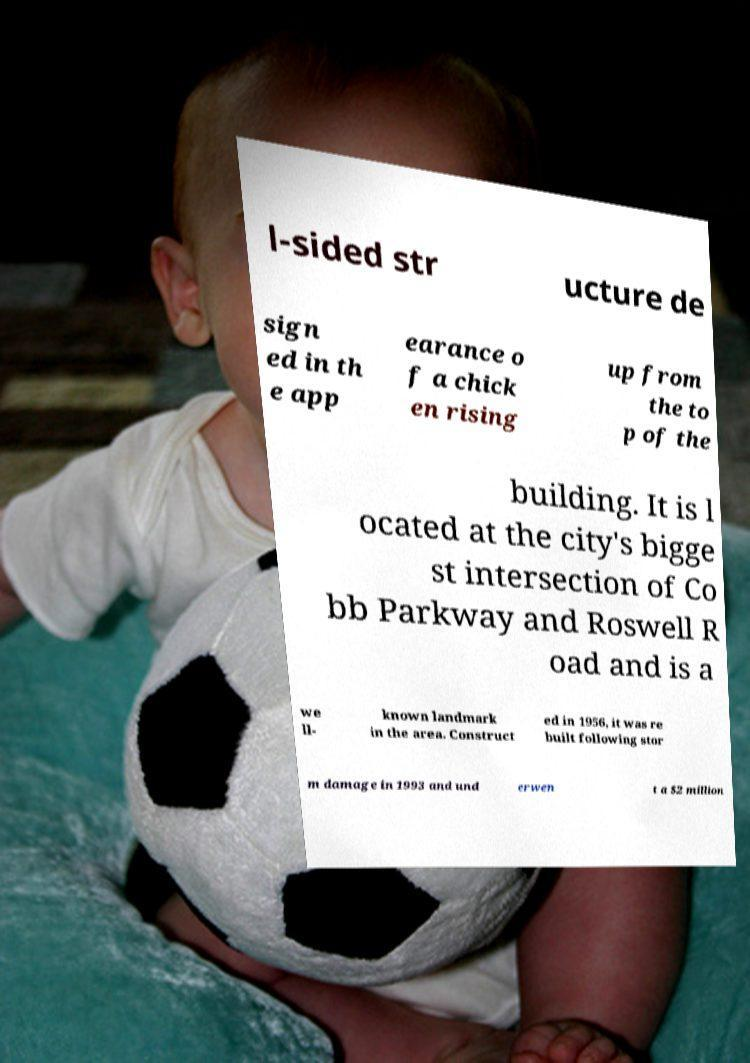Please read and relay the text visible in this image. What does it say? l-sided str ucture de sign ed in th e app earance o f a chick en rising up from the to p of the building. It is l ocated at the city's bigge st intersection of Co bb Parkway and Roswell R oad and is a we ll- known landmark in the area. Construct ed in 1956, it was re built following stor m damage in 1993 and und erwen t a $2 million 